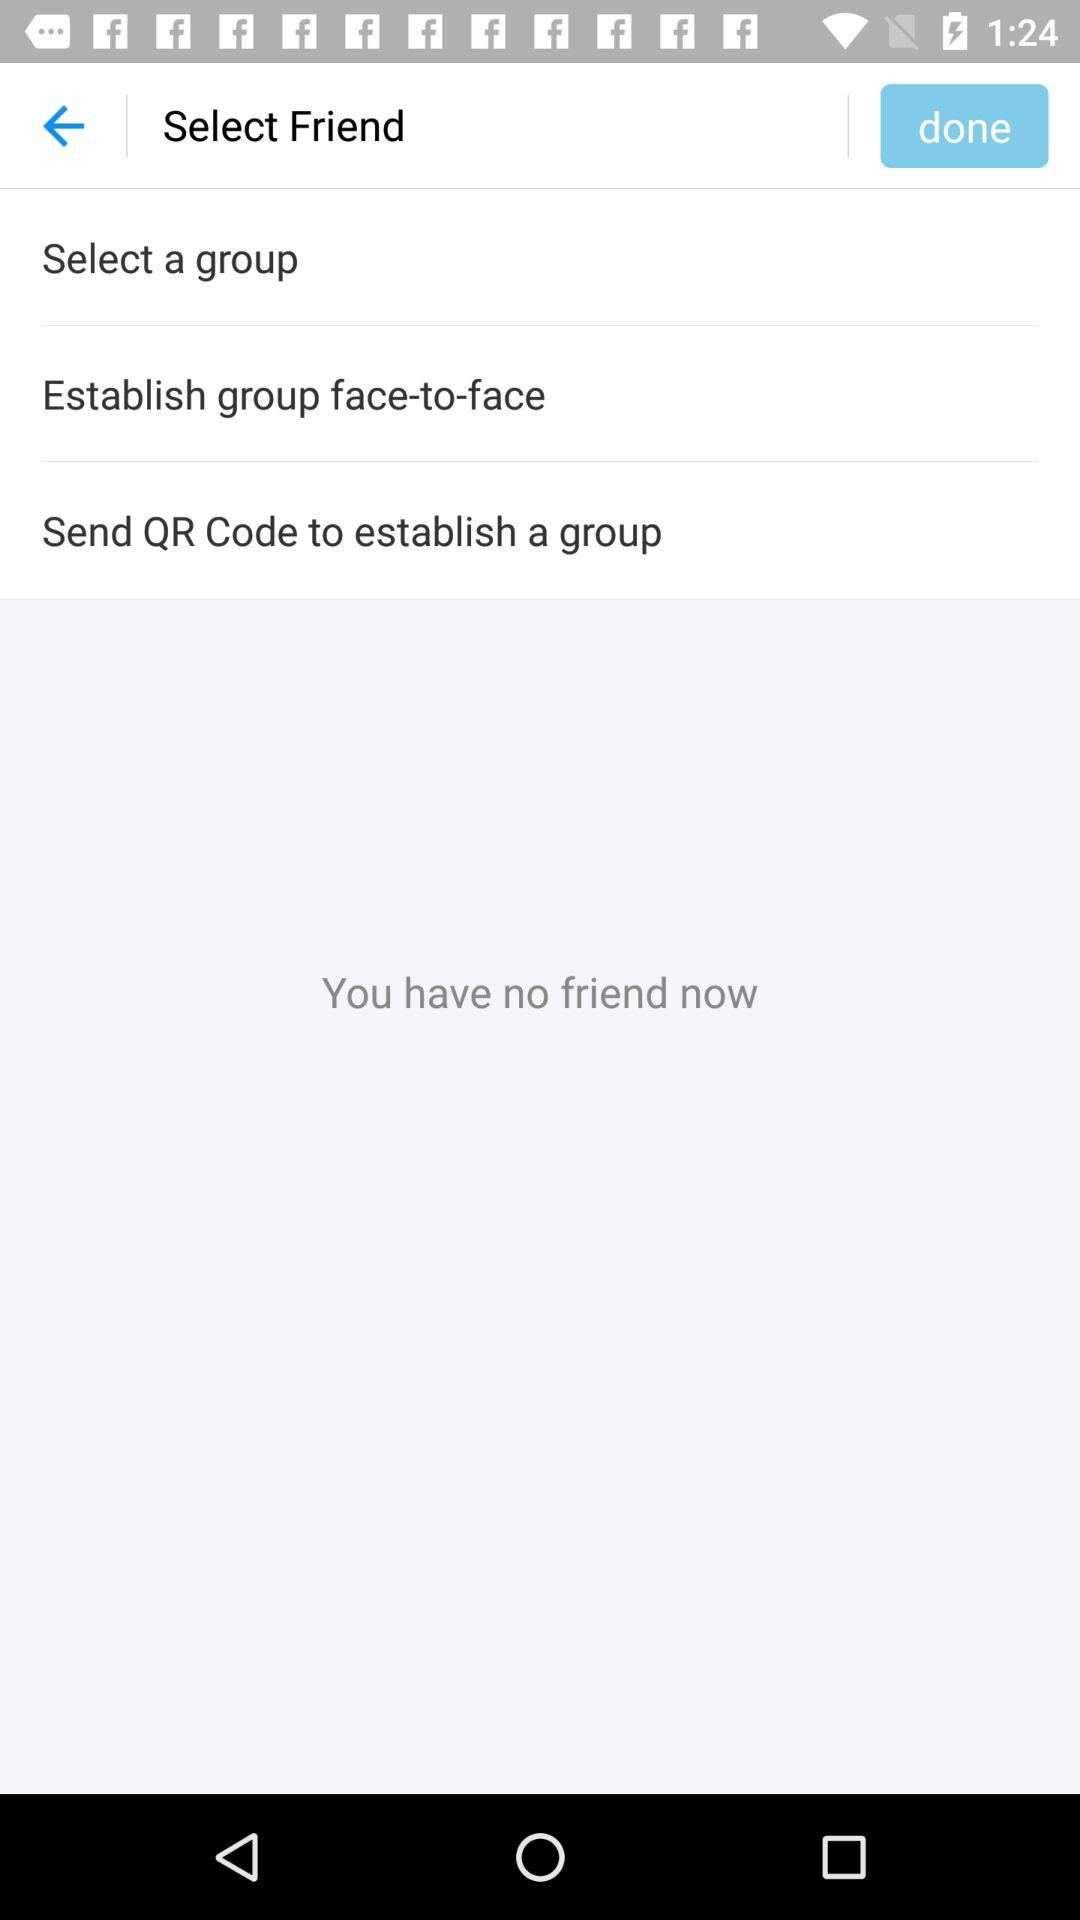Are there any friends? There is no friend. 